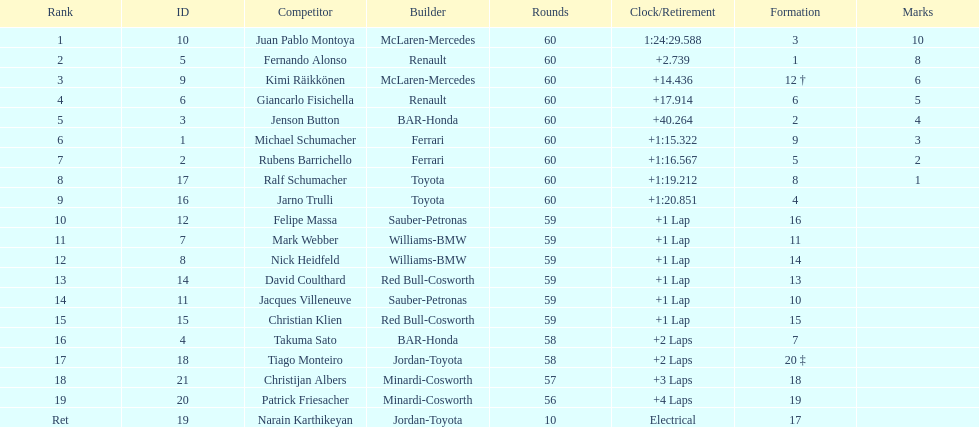Which driver in the top 8, drives a mclaran-mercedes but is not in first place? Kimi Räikkönen. 